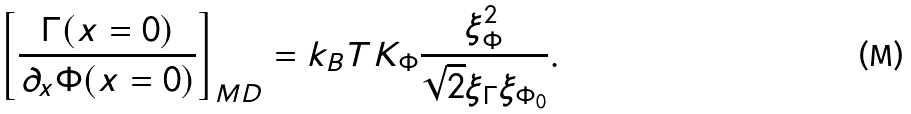<formula> <loc_0><loc_0><loc_500><loc_500>\left [ \frac { \Gamma ( x = 0 ) } { \partial _ { x } \Phi ( x = 0 ) } \right ] _ { M D } = k _ { B } T K _ { \Phi } \frac { \xi _ { \Phi } ^ { 2 } } { \sqrt { 2 } \xi _ { \Gamma } \xi _ { \Phi _ { 0 } } } .</formula> 